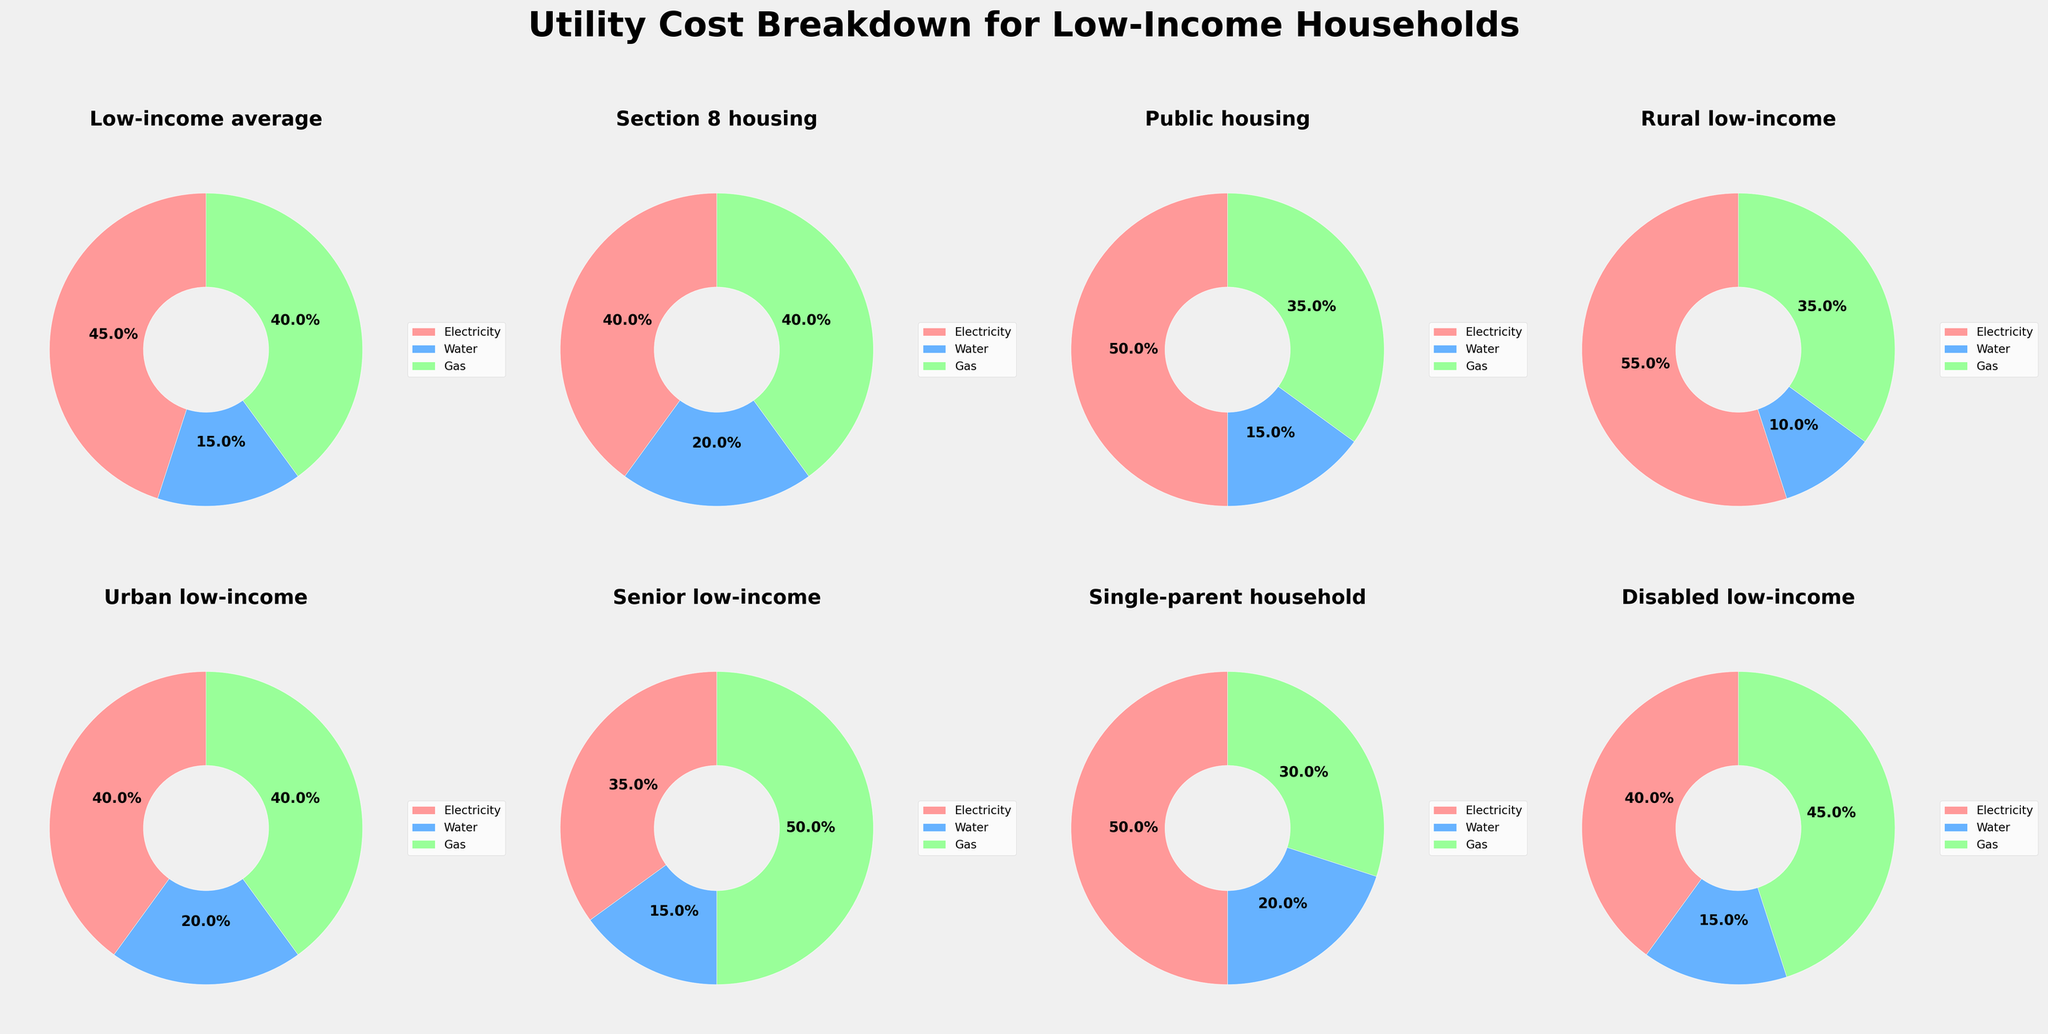What's the breakdown of utility costs for Section 8 housing? Looking at the pie chart for Section 8 housing, the breakdown is visually represented by the segments of the pie chart. From the visual, electricity takes up 40%, water takes up 20%, and gas takes up 40%.
Answer: 40% electricity, 20% water, 40% gas Which category has the highest percentage of gas costs? By observing all the pie charts, the "Senior low-income" category has the largest segment for gas costs, which is 50%, higher than in any other category.
Answer: Senior low-income What is the difference in electricity costs between Rural low-income and Urban low-income households? The electricity cost for Rural low-income is 55% and for Urban low-income it is 40%. The difference is calculated by subtracting 40% from 55%.
Answer: 15% What is the average percentage of water costs across all categories? To find the average water cost, sum up the water percentages from all categories (15 + 20 + 15 + 10 + 20 + 15 + 20 + 15) which equals 130. Then, divide by the number of categories, which is 8. This results in an average of 16.25%.
Answer: 16.25% Which category has the smallest percentage of water costs? By looking at the pie charts, the category "Rural low-income" has the smallest segment for water costs, which is 10%.
Answer: Rural low-income What's the total percentage of utility costs attributed to gas and electricity combined for Disabled low-income households? For Disabled low-income households, electricity is 40% and gas is 45%. Adding these two percentages together gives a total of 85%.
Answer: 85% How do electricity costs for Public housing compare to Single-parent households? Public housing shows an electricity cost of 50%, while Single-parent households also have an electricity cost of 50%. Hence, they are equal.
Answer: Equal Which category devotes the largest percentage to water? By comparing all the pie charts, the "Section 8 housing" and "Single-parent household" categories both allocate 20% to water, which is the highest among all categories.
Answer: Section 8 housing, Single-parent household What's the sum of the electricity and gas percentages for the category with the highest water cost? First, identify that the highest water cost is found in both Section 8 housing and Single-parent households, both at 20%. For Section 8 housing, electricity and gas are 40% and 40%, respectively. For Single-parent households, electricity is 50% and gas is 30%. Adding these up for both categories: Section 8 housing (40% + 40%) = 80%, Single-parent households (50% + 30%) = 80%.
Answer: 80% Which category has equal percentages for gas and electricity costs? By looking at the pies, "Section 8 housing" and "Urban low-income" categories both have 40% for electricity and 40% for gas, making them equal.
Answer: Section 8 housing, Urban low-income 